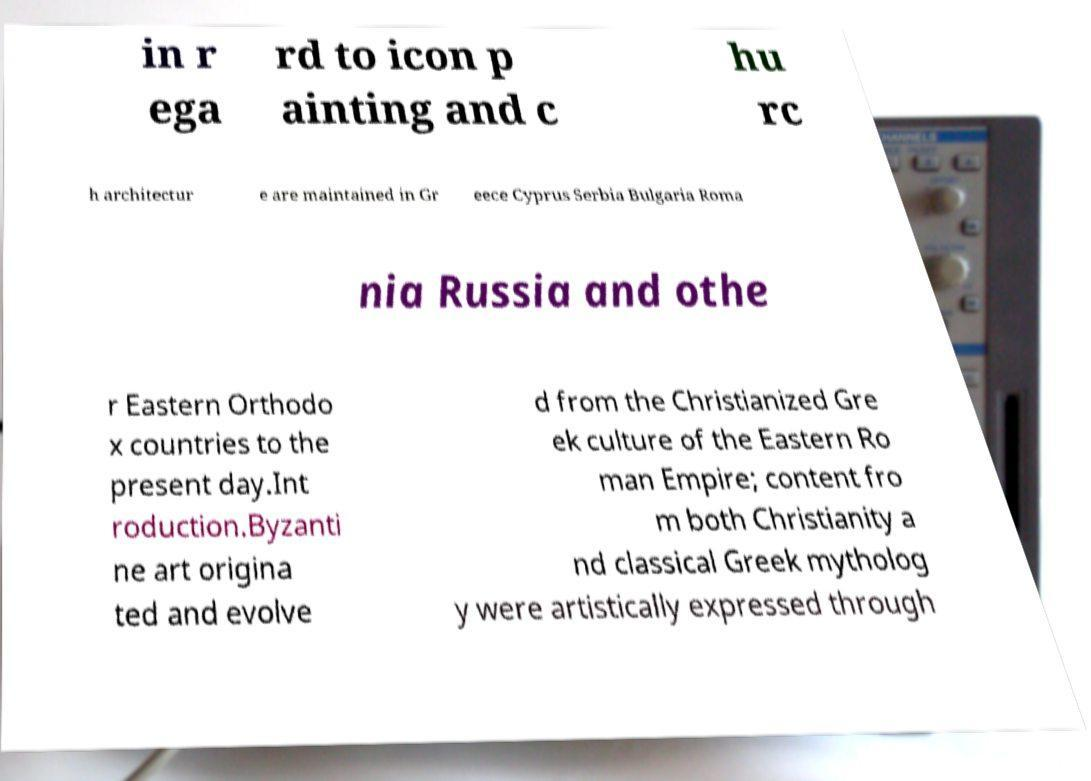Could you assist in decoding the text presented in this image and type it out clearly? in r ega rd to icon p ainting and c hu rc h architectur e are maintained in Gr eece Cyprus Serbia Bulgaria Roma nia Russia and othe r Eastern Orthodo x countries to the present day.Int roduction.Byzanti ne art origina ted and evolve d from the Christianized Gre ek culture of the Eastern Ro man Empire; content fro m both Christianity a nd classical Greek mytholog y were artistically expressed through 